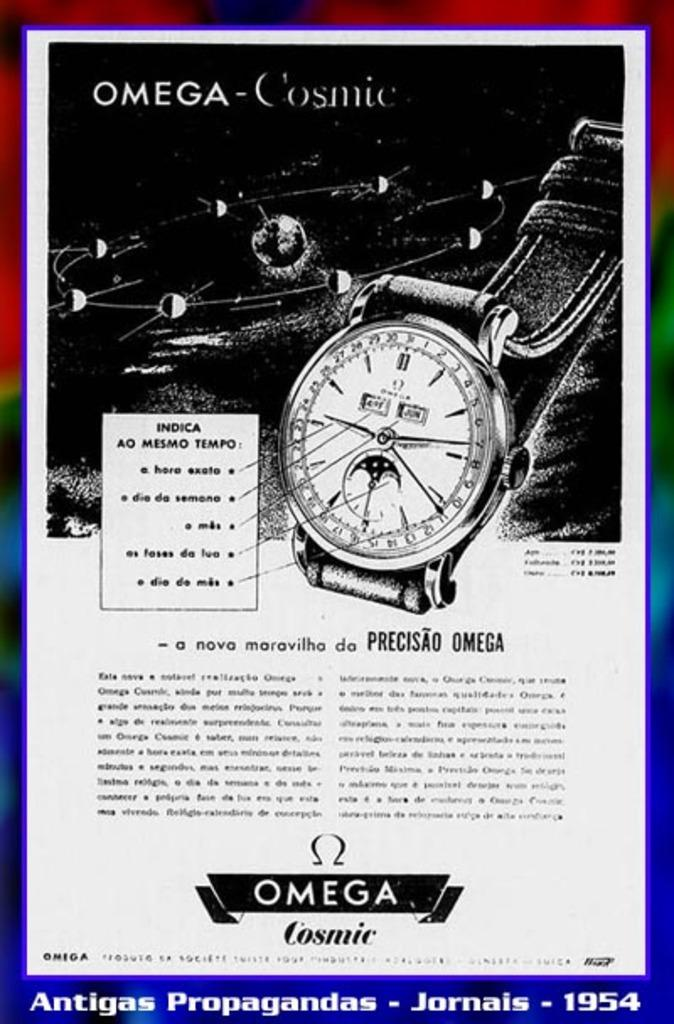<image>
Share a concise interpretation of the image provided. An Omega watch advertisement that in black an white. 